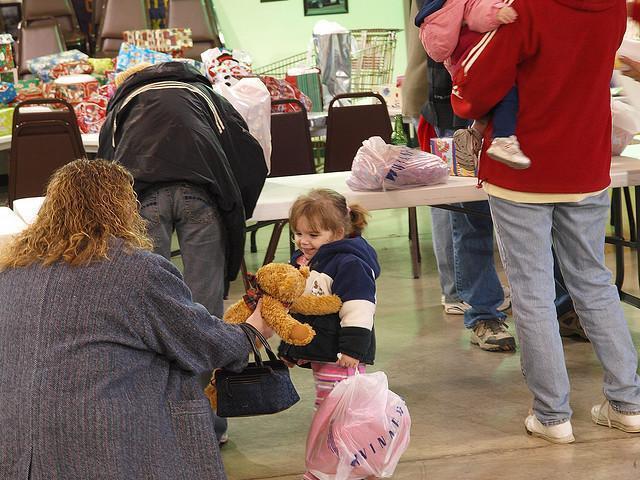How many people are there?
Give a very brief answer. 7. How many chairs are in the photo?
Give a very brief answer. 4. 